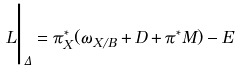<formula> <loc_0><loc_0><loc_500><loc_500>L \Big | _ { \Delta } = \pi _ { X } ^ { * } ( \omega _ { X / B } + D + \pi ^ { * } M ) - E</formula> 